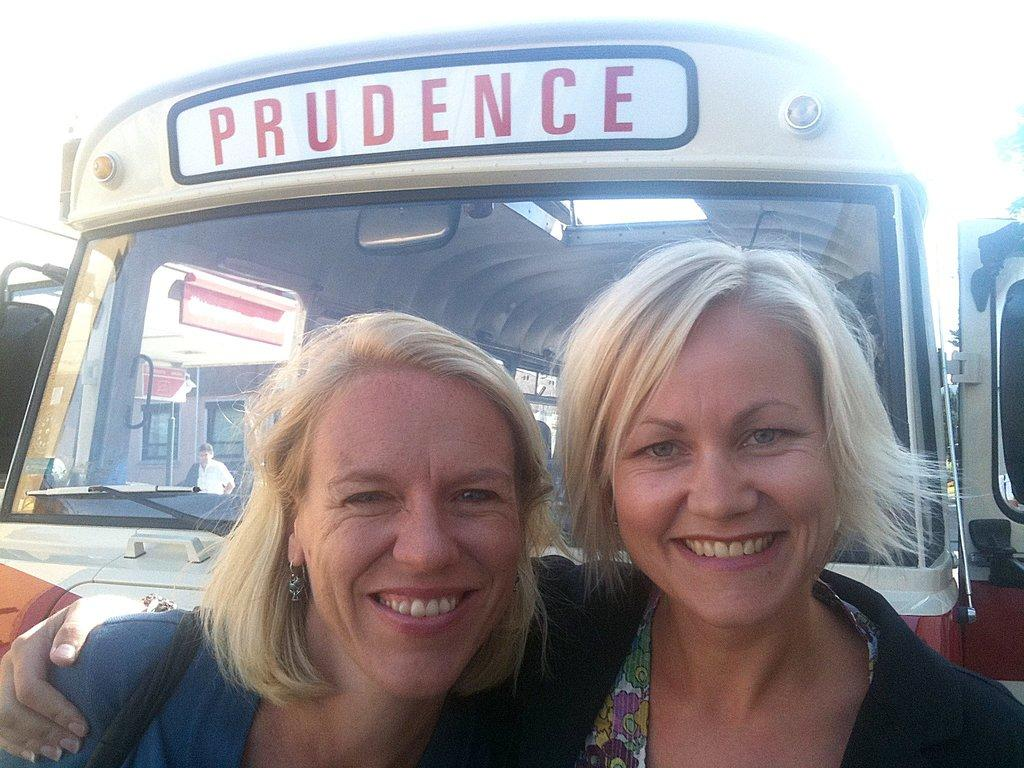How many people are in the foreground of the image? There are two lady persons in the foreground of the image. What are the lady persons doing in the image? The lady persons are hugging each other. What can be seen in the background of the image? There are buses in the background of the image. What type of acoustics can be heard in the image? There is no information about sounds or acoustics in the image, so it cannot be determined. 